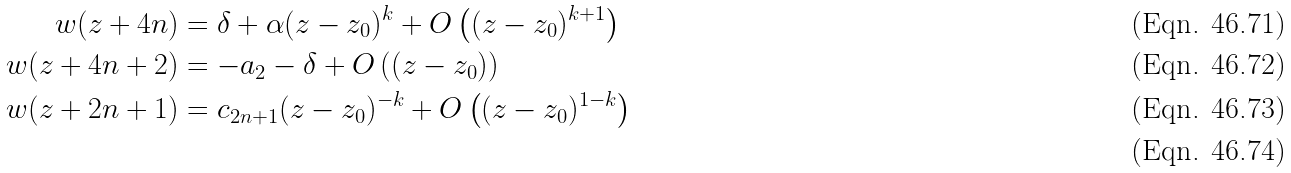<formula> <loc_0><loc_0><loc_500><loc_500>w ( z + 4 n ) & = \delta + \alpha ( z - z _ { 0 } ) ^ { k } + O \left ( ( z - z _ { 0 } ) ^ { k + 1 } \right ) \\ w ( z + 4 n + 2 ) & = - a _ { 2 } - \delta + O \left ( ( z - z _ { 0 } ) \right ) \\ w ( z + 2 n + 1 ) & = c _ { 2 n + 1 } ( z - z _ { 0 } ) ^ { - k } + O \left ( ( z - z _ { 0 } ) ^ { 1 - k } \right ) \\</formula> 